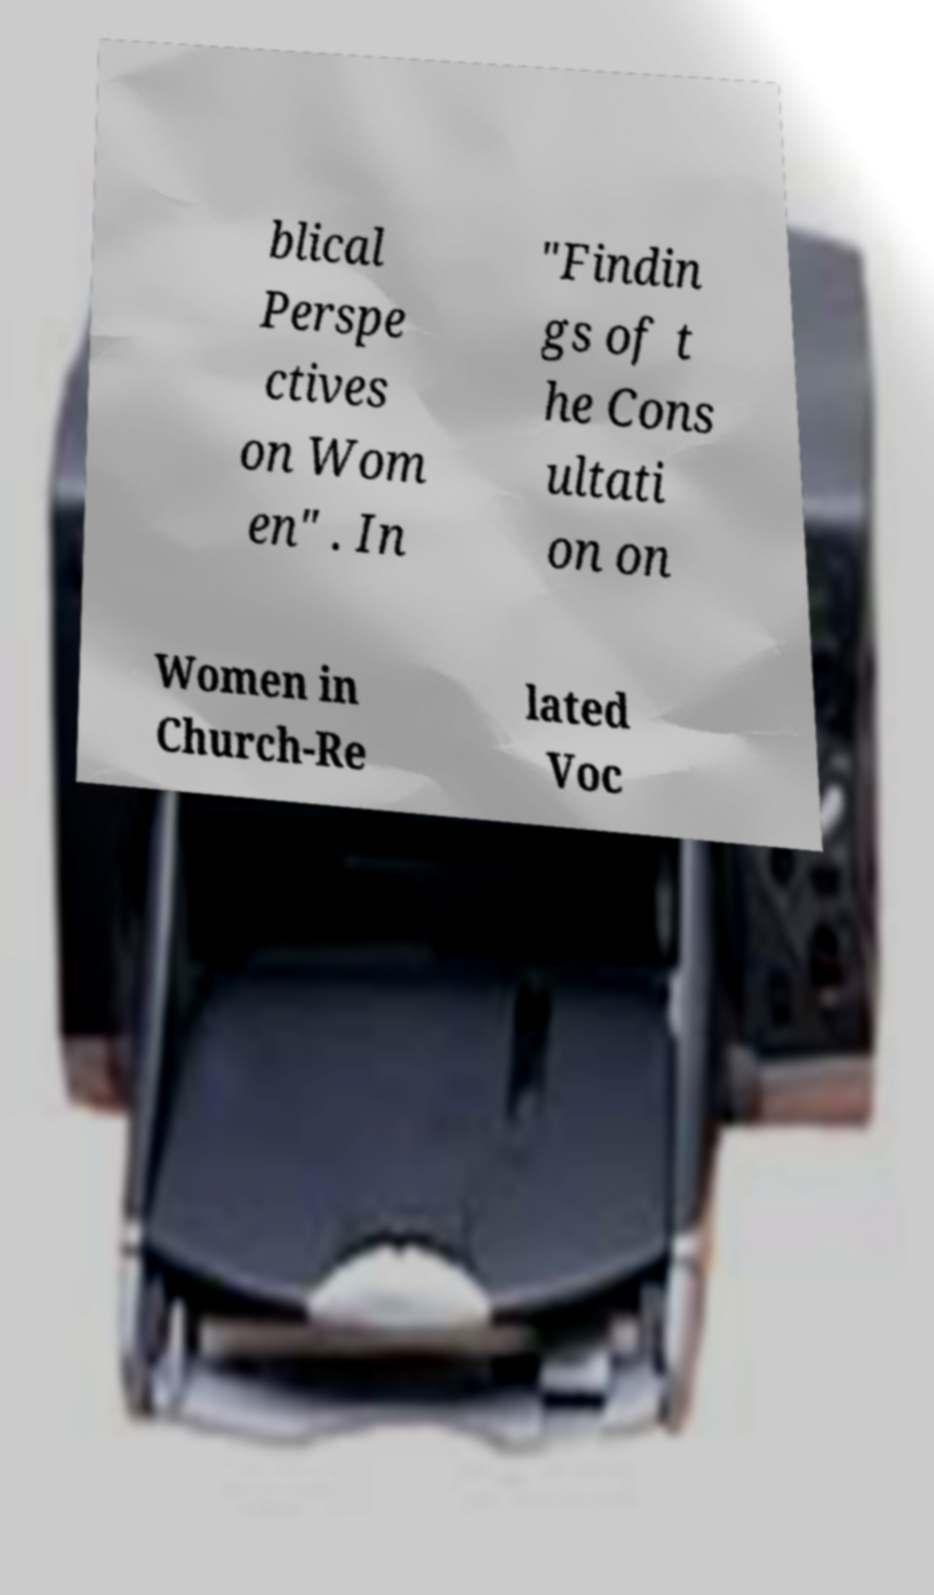For documentation purposes, I need the text within this image transcribed. Could you provide that? blical Perspe ctives on Wom en" . In "Findin gs of t he Cons ultati on on Women in Church-Re lated Voc 